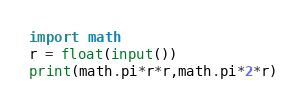<code> <loc_0><loc_0><loc_500><loc_500><_Python_>import math
r = float(input())
print(math.pi*r*r,math.pi*2*r)
</code> 